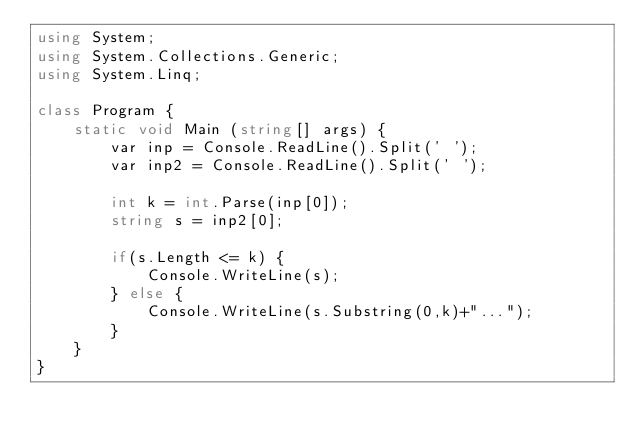Convert code to text. <code><loc_0><loc_0><loc_500><loc_500><_C#_>using System;
using System.Collections.Generic;
using System.Linq;

class Program {
    static void Main (string[] args) {
        var inp = Console.ReadLine().Split(' ');
        var inp2 = Console.ReadLine().Split(' ');

        int k = int.Parse(inp[0]);
        string s = inp2[0];

        if(s.Length <= k) {
            Console.WriteLine(s);
        } else {
            Console.WriteLine(s.Substring(0,k)+"...");
        }
    }
}</code> 